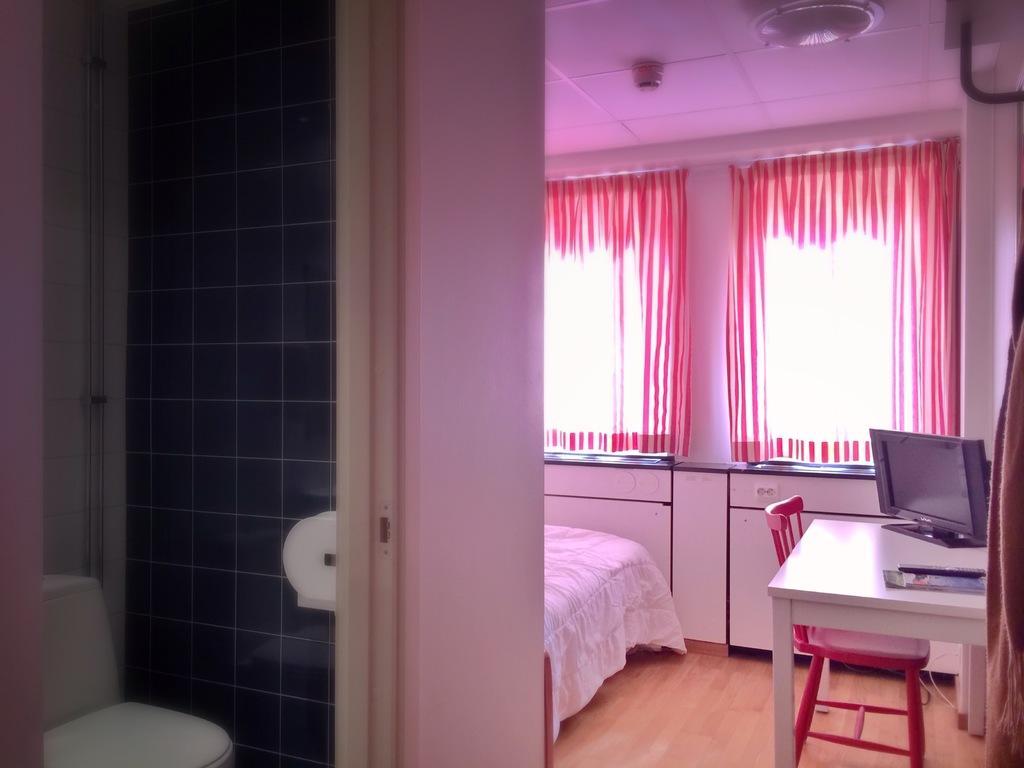In one or two sentences, can you explain what this image depicts? In this image I can see a toilet seat, the black colored wall, the white colored wall, the ceiling, a white colored table with a monitor on it, a red colored chair, a bed, the ceiling, few windows and the curtain which is red and white in color. 